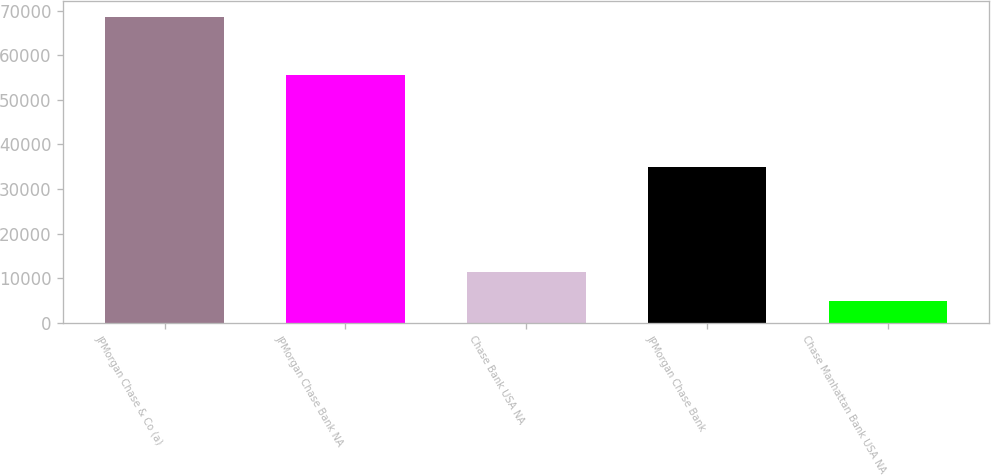Convert chart. <chart><loc_0><loc_0><loc_500><loc_500><bar_chart><fcel>JPMorgan Chase & Co (a)<fcel>JPMorgan Chase Bank NA<fcel>Chase Bank USA NA<fcel>JPMorgan Chase Bank<fcel>Chase Manhattan Bank USA NA<nl><fcel>68621<fcel>55489<fcel>11317.1<fcel>34972<fcel>4950<nl></chart> 